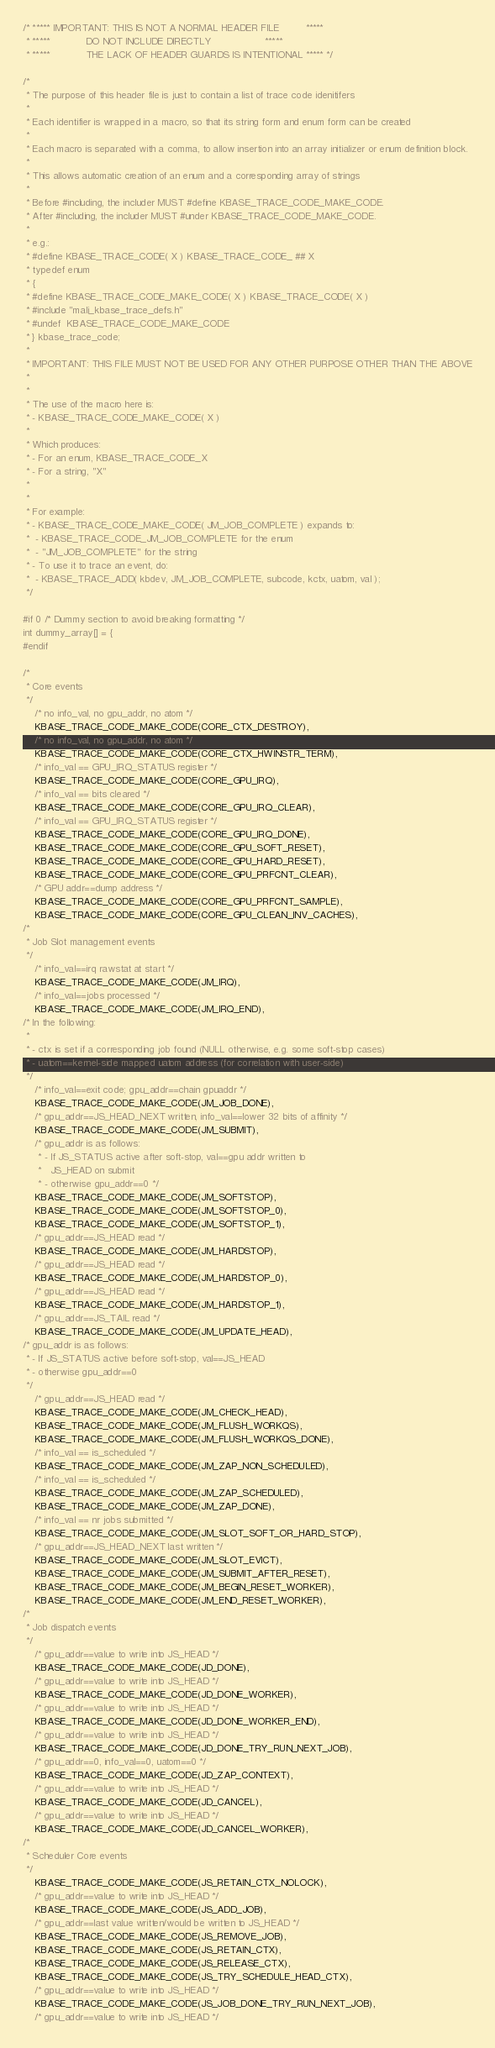Convert code to text. <code><loc_0><loc_0><loc_500><loc_500><_C_>
/* ***** IMPORTANT: THIS IS NOT A NORMAL HEADER FILE         *****
 * *****            DO NOT INCLUDE DIRECTLY                  *****
 * *****            THE LACK OF HEADER GUARDS IS INTENTIONAL ***** */

/*
 * The purpose of this header file is just to contain a list of trace code idenitifers
 *
 * Each identifier is wrapped in a macro, so that its string form and enum form can be created
 *
 * Each macro is separated with a comma, to allow insertion into an array initializer or enum definition block.
 *
 * This allows automatic creation of an enum and a corresponding array of strings
 *
 * Before #including, the includer MUST #define KBASE_TRACE_CODE_MAKE_CODE.
 * After #including, the includer MUST #under KBASE_TRACE_CODE_MAKE_CODE.
 *
 * e.g.:
 * #define KBASE_TRACE_CODE( X ) KBASE_TRACE_CODE_ ## X
 * typedef enum
 * {
 * #define KBASE_TRACE_CODE_MAKE_CODE( X ) KBASE_TRACE_CODE( X )
 * #include "mali_kbase_trace_defs.h"
 * #undef  KBASE_TRACE_CODE_MAKE_CODE
 * } kbase_trace_code;
 *
 * IMPORTANT: THIS FILE MUST NOT BE USED FOR ANY OTHER PURPOSE OTHER THAN THE ABOVE
 *
 *
 * The use of the macro here is:
 * - KBASE_TRACE_CODE_MAKE_CODE( X )
 *
 * Which produces:
 * - For an enum, KBASE_TRACE_CODE_X
 * - For a string, "X"
 *
 *
 * For example:
 * - KBASE_TRACE_CODE_MAKE_CODE( JM_JOB_COMPLETE ) expands to:
 *  - KBASE_TRACE_CODE_JM_JOB_COMPLETE for the enum
 *  - "JM_JOB_COMPLETE" for the string
 * - To use it to trace an event, do:
 *  - KBASE_TRACE_ADD( kbdev, JM_JOB_COMPLETE, subcode, kctx, uatom, val );
 */

#if 0 /* Dummy section to avoid breaking formatting */
int dummy_array[] = {
#endif

/*
 * Core events
 */
	/* no info_val, no gpu_addr, no atom */
	KBASE_TRACE_CODE_MAKE_CODE(CORE_CTX_DESTROY),
	/* no info_val, no gpu_addr, no atom */
	KBASE_TRACE_CODE_MAKE_CODE(CORE_CTX_HWINSTR_TERM),
	/* info_val == GPU_IRQ_STATUS register */
	KBASE_TRACE_CODE_MAKE_CODE(CORE_GPU_IRQ),
	/* info_val == bits cleared */
	KBASE_TRACE_CODE_MAKE_CODE(CORE_GPU_IRQ_CLEAR),
	/* info_val == GPU_IRQ_STATUS register */
	KBASE_TRACE_CODE_MAKE_CODE(CORE_GPU_IRQ_DONE),
	KBASE_TRACE_CODE_MAKE_CODE(CORE_GPU_SOFT_RESET),
	KBASE_TRACE_CODE_MAKE_CODE(CORE_GPU_HARD_RESET),
	KBASE_TRACE_CODE_MAKE_CODE(CORE_GPU_PRFCNT_CLEAR),
	/* GPU addr==dump address */
	KBASE_TRACE_CODE_MAKE_CODE(CORE_GPU_PRFCNT_SAMPLE),
	KBASE_TRACE_CODE_MAKE_CODE(CORE_GPU_CLEAN_INV_CACHES),
/*
 * Job Slot management events
 */
	/* info_val==irq rawstat at start */
	KBASE_TRACE_CODE_MAKE_CODE(JM_IRQ),
	/* info_val==jobs processed */
	KBASE_TRACE_CODE_MAKE_CODE(JM_IRQ_END),
/* In the following:
 *
 * - ctx is set if a corresponding job found (NULL otherwise, e.g. some soft-stop cases)
 * - uatom==kernel-side mapped uatom address (for correlation with user-side)
 */
	/* info_val==exit code; gpu_addr==chain gpuaddr */
	KBASE_TRACE_CODE_MAKE_CODE(JM_JOB_DONE),
	/* gpu_addr==JS_HEAD_NEXT written, info_val==lower 32 bits of affinity */
	KBASE_TRACE_CODE_MAKE_CODE(JM_SUBMIT),
	/* gpu_addr is as follows:
	 * - If JS_STATUS active after soft-stop, val==gpu addr written to
	 *   JS_HEAD on submit
	 * - otherwise gpu_addr==0 */
	KBASE_TRACE_CODE_MAKE_CODE(JM_SOFTSTOP),
	KBASE_TRACE_CODE_MAKE_CODE(JM_SOFTSTOP_0),
	KBASE_TRACE_CODE_MAKE_CODE(JM_SOFTSTOP_1),
	/* gpu_addr==JS_HEAD read */
	KBASE_TRACE_CODE_MAKE_CODE(JM_HARDSTOP),
	/* gpu_addr==JS_HEAD read */
	KBASE_TRACE_CODE_MAKE_CODE(JM_HARDSTOP_0),
	/* gpu_addr==JS_HEAD read */
	KBASE_TRACE_CODE_MAKE_CODE(JM_HARDSTOP_1),
	/* gpu_addr==JS_TAIL read */
	KBASE_TRACE_CODE_MAKE_CODE(JM_UPDATE_HEAD),
/* gpu_addr is as follows:
 * - If JS_STATUS active before soft-stop, val==JS_HEAD
 * - otherwise gpu_addr==0
 */
	/* gpu_addr==JS_HEAD read */
	KBASE_TRACE_CODE_MAKE_CODE(JM_CHECK_HEAD),
	KBASE_TRACE_CODE_MAKE_CODE(JM_FLUSH_WORKQS),
	KBASE_TRACE_CODE_MAKE_CODE(JM_FLUSH_WORKQS_DONE),
	/* info_val == is_scheduled */
	KBASE_TRACE_CODE_MAKE_CODE(JM_ZAP_NON_SCHEDULED),
	/* info_val == is_scheduled */
	KBASE_TRACE_CODE_MAKE_CODE(JM_ZAP_SCHEDULED),
	KBASE_TRACE_CODE_MAKE_CODE(JM_ZAP_DONE),
	/* info_val == nr jobs submitted */
	KBASE_TRACE_CODE_MAKE_CODE(JM_SLOT_SOFT_OR_HARD_STOP),
	/* gpu_addr==JS_HEAD_NEXT last written */
	KBASE_TRACE_CODE_MAKE_CODE(JM_SLOT_EVICT),
	KBASE_TRACE_CODE_MAKE_CODE(JM_SUBMIT_AFTER_RESET),
	KBASE_TRACE_CODE_MAKE_CODE(JM_BEGIN_RESET_WORKER),
	KBASE_TRACE_CODE_MAKE_CODE(JM_END_RESET_WORKER),
/*
 * Job dispatch events
 */
	/* gpu_addr==value to write into JS_HEAD */
	KBASE_TRACE_CODE_MAKE_CODE(JD_DONE),
	/* gpu_addr==value to write into JS_HEAD */
	KBASE_TRACE_CODE_MAKE_CODE(JD_DONE_WORKER),
	/* gpu_addr==value to write into JS_HEAD */
	KBASE_TRACE_CODE_MAKE_CODE(JD_DONE_WORKER_END),
	/* gpu_addr==value to write into JS_HEAD */
	KBASE_TRACE_CODE_MAKE_CODE(JD_DONE_TRY_RUN_NEXT_JOB),
	/* gpu_addr==0, info_val==0, uatom==0 */
	KBASE_TRACE_CODE_MAKE_CODE(JD_ZAP_CONTEXT),
	/* gpu_addr==value to write into JS_HEAD */
	KBASE_TRACE_CODE_MAKE_CODE(JD_CANCEL),
	/* gpu_addr==value to write into JS_HEAD */
	KBASE_TRACE_CODE_MAKE_CODE(JD_CANCEL_WORKER),
/*
 * Scheduler Core events
 */
	KBASE_TRACE_CODE_MAKE_CODE(JS_RETAIN_CTX_NOLOCK),
	/* gpu_addr==value to write into JS_HEAD */
	KBASE_TRACE_CODE_MAKE_CODE(JS_ADD_JOB),
	/* gpu_addr==last value written/would be written to JS_HEAD */
	KBASE_TRACE_CODE_MAKE_CODE(JS_REMOVE_JOB),
	KBASE_TRACE_CODE_MAKE_CODE(JS_RETAIN_CTX),
	KBASE_TRACE_CODE_MAKE_CODE(JS_RELEASE_CTX),
	KBASE_TRACE_CODE_MAKE_CODE(JS_TRY_SCHEDULE_HEAD_CTX),
	/* gpu_addr==value to write into JS_HEAD */
	KBASE_TRACE_CODE_MAKE_CODE(JS_JOB_DONE_TRY_RUN_NEXT_JOB),
	/* gpu_addr==value to write into JS_HEAD */</code> 